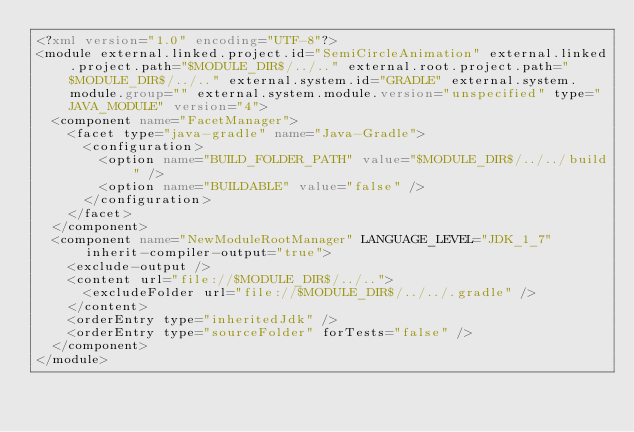Convert code to text. <code><loc_0><loc_0><loc_500><loc_500><_XML_><?xml version="1.0" encoding="UTF-8"?>
<module external.linked.project.id="SemiCircleAnimation" external.linked.project.path="$MODULE_DIR$/../.." external.root.project.path="$MODULE_DIR$/../.." external.system.id="GRADLE" external.system.module.group="" external.system.module.version="unspecified" type="JAVA_MODULE" version="4">
  <component name="FacetManager">
    <facet type="java-gradle" name="Java-Gradle">
      <configuration>
        <option name="BUILD_FOLDER_PATH" value="$MODULE_DIR$/../../build" />
        <option name="BUILDABLE" value="false" />
      </configuration>
    </facet>
  </component>
  <component name="NewModuleRootManager" LANGUAGE_LEVEL="JDK_1_7" inherit-compiler-output="true">
    <exclude-output />
    <content url="file://$MODULE_DIR$/../..">
      <excludeFolder url="file://$MODULE_DIR$/../../.gradle" />
    </content>
    <orderEntry type="inheritedJdk" />
    <orderEntry type="sourceFolder" forTests="false" />
  </component>
</module></code> 